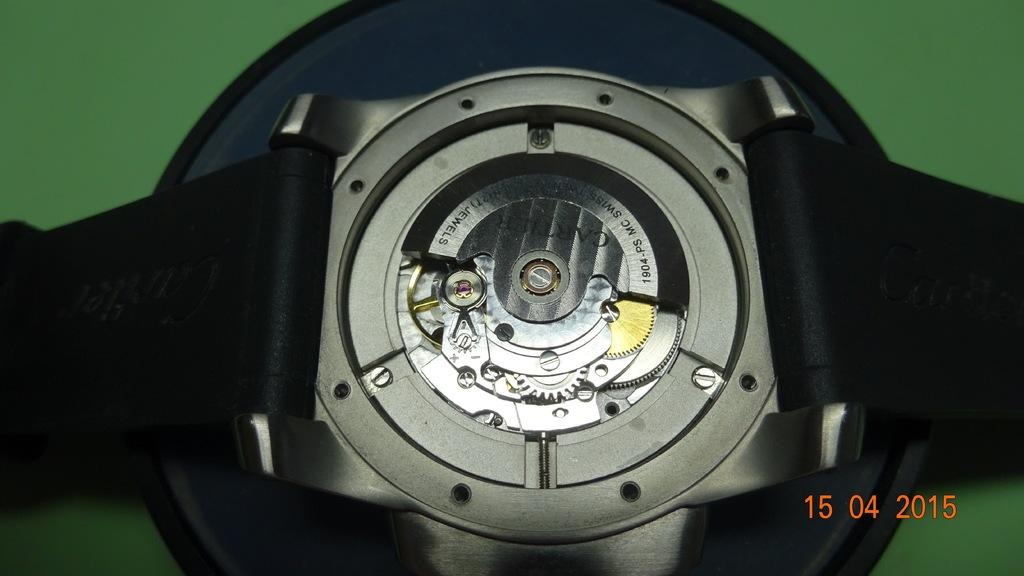What type of objects are in the image? There are belts and a device in the image. Can you describe the background of the image? The background of the image is green. What type of oven is visible in the image? There is no oven present in the image. What type of connection is being used by the device in the image? The image does not provide information about the type of connection being used by the device. 